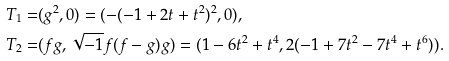<formula> <loc_0><loc_0><loc_500><loc_500>T _ { 1 } = & ( g ^ { 2 } , 0 ) = ( - ( - 1 + 2 t + t ^ { 2 } ) ^ { 2 } , 0 ) , \\ T _ { 2 } = & ( f g , \sqrt { - 1 } f ( f - g ) g ) = ( 1 - 6 t ^ { 2 } + t ^ { 4 } , 2 ( - 1 + 7 t ^ { 2 } - 7 t ^ { 4 } + t ^ { 6 } ) ) .</formula> 